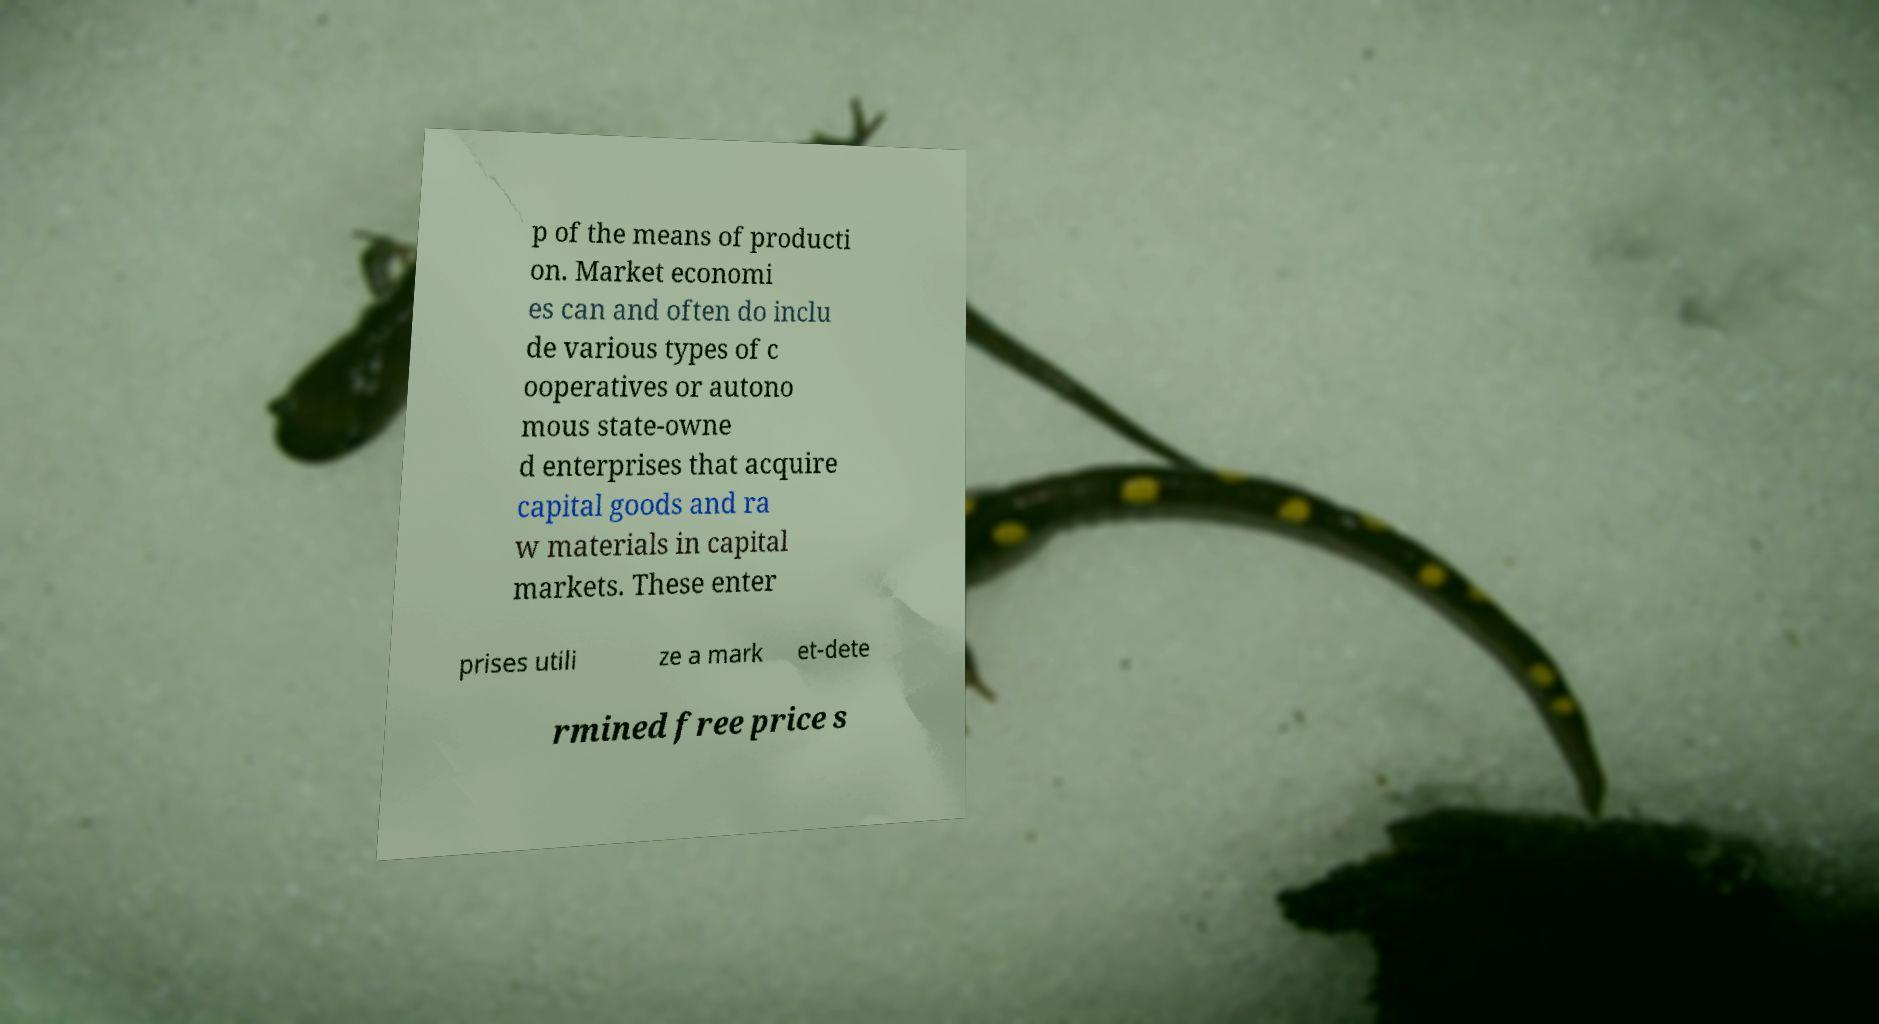Please read and relay the text visible in this image. What does it say? p of the means of producti on. Market economi es can and often do inclu de various types of c ooperatives or autono mous state-owne d enterprises that acquire capital goods and ra w materials in capital markets. These enter prises utili ze a mark et-dete rmined free price s 